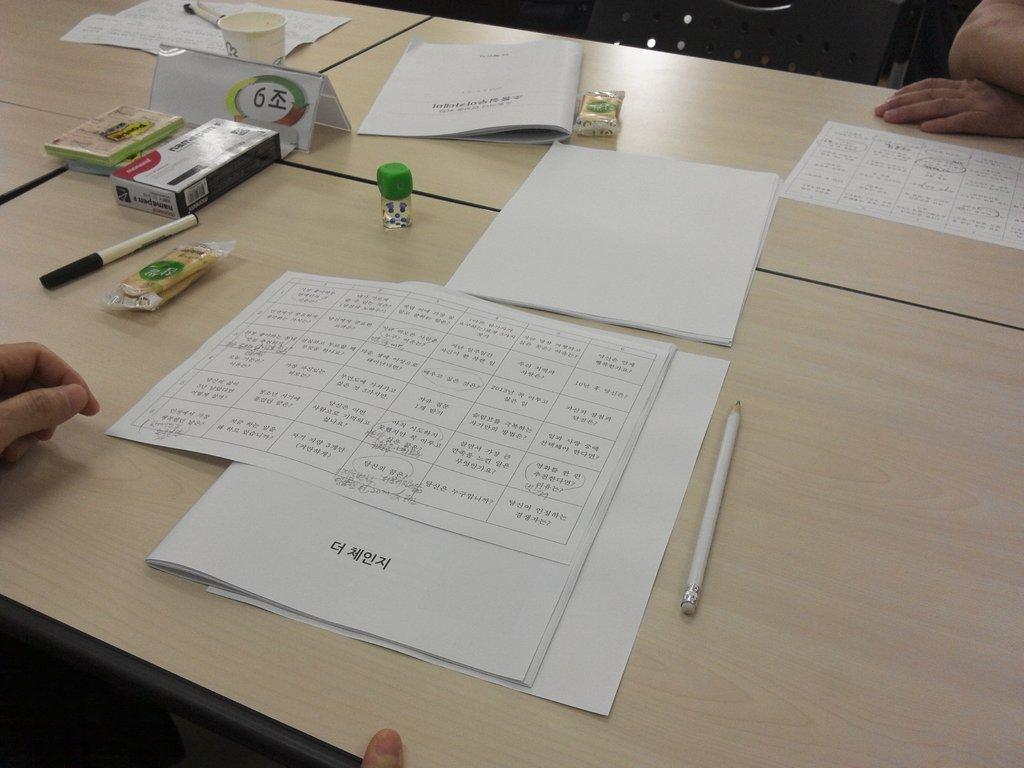What is the main object in the image? There is a table in the image. What items can be seen on the table? There are papers, pens, and other stationery items on the table. Can you describe the stationery items on the table? The stationery items on the table include pens, but the specific types of other stationery items are not mentioned. How many trees are visible in the image? There are no trees visible in the image; it only features a table with various items on it. Are there any dinosaurs present in the image? No, there are no dinosaurs present in the image. 